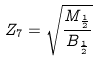Convert formula to latex. <formula><loc_0><loc_0><loc_500><loc_500>Z _ { 7 } = \sqrt { \frac { M _ { \frac { 1 } { 2 } } } { B _ { \frac { 1 } { 2 } } } }</formula> 